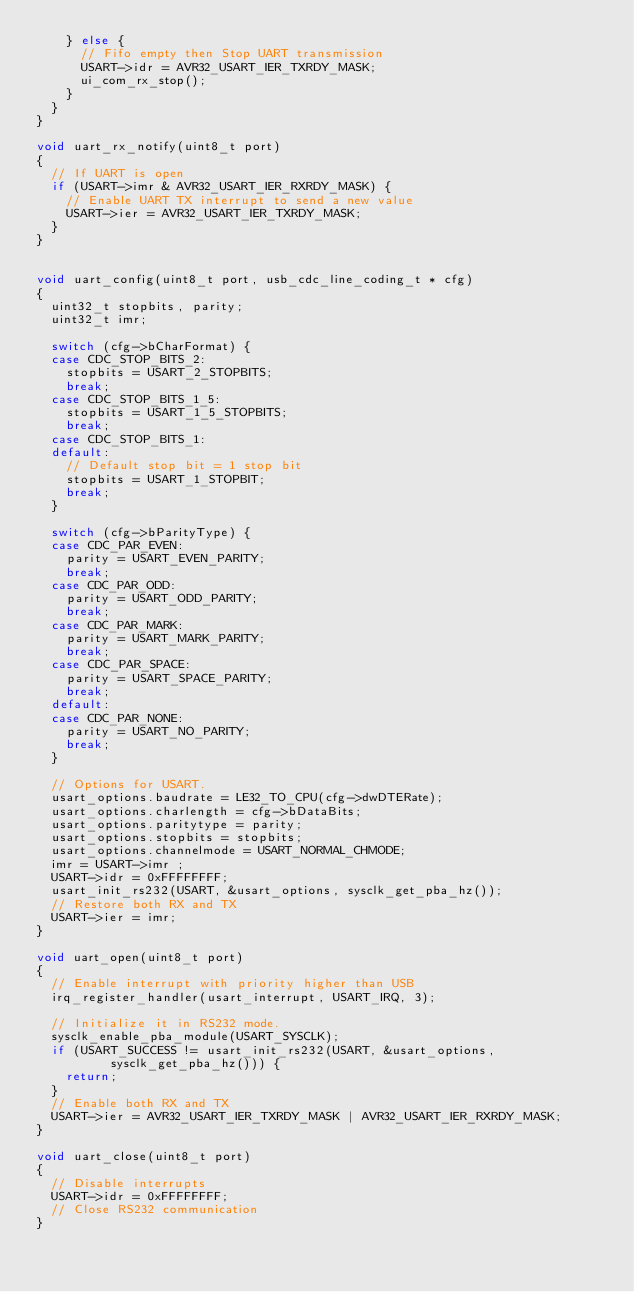<code> <loc_0><loc_0><loc_500><loc_500><_C_>		} else {
			// Fifo empty then Stop UART transmission
			USART->idr = AVR32_USART_IER_TXRDY_MASK;
			ui_com_rx_stop();
		}
	}
}

void uart_rx_notify(uint8_t port)
{
	// If UART is open
	if (USART->imr & AVR32_USART_IER_RXRDY_MASK) {
		// Enable UART TX interrupt to send a new value
		USART->ier = AVR32_USART_IER_TXRDY_MASK;
	}
}


void uart_config(uint8_t port, usb_cdc_line_coding_t * cfg)
{
	uint32_t stopbits, parity;
	uint32_t imr;

	switch (cfg->bCharFormat) {
	case CDC_STOP_BITS_2:
		stopbits = USART_2_STOPBITS;
		break;
	case CDC_STOP_BITS_1_5:
		stopbits = USART_1_5_STOPBITS;
		break;
	case CDC_STOP_BITS_1:
	default:
		// Default stop bit = 1 stop bit
		stopbits = USART_1_STOPBIT;
		break;
	}

	switch (cfg->bParityType) {
	case CDC_PAR_EVEN:
		parity = USART_EVEN_PARITY;
		break;
	case CDC_PAR_ODD:
		parity = USART_ODD_PARITY;
		break;
	case CDC_PAR_MARK:
		parity = USART_MARK_PARITY;
		break;
	case CDC_PAR_SPACE:
		parity = USART_SPACE_PARITY;
		break;
	default:
	case CDC_PAR_NONE:
		parity = USART_NO_PARITY;
		break;
	}

	// Options for USART.
	usart_options.baudrate = LE32_TO_CPU(cfg->dwDTERate);
	usart_options.charlength = cfg->bDataBits;
	usart_options.paritytype = parity;
	usart_options.stopbits = stopbits;
	usart_options.channelmode = USART_NORMAL_CHMODE;
	imr = USART->imr ;
	USART->idr = 0xFFFFFFFF;
	usart_init_rs232(USART, &usart_options, sysclk_get_pba_hz());
	// Restore both RX and TX
	USART->ier = imr;
}

void uart_open(uint8_t port)
{
	// Enable interrupt with priority higher than USB
	irq_register_handler(usart_interrupt, USART_IRQ, 3);

	// Initialize it in RS232 mode.
	sysclk_enable_pba_module(USART_SYSCLK);
	if (USART_SUCCESS != usart_init_rs232(USART, &usart_options,
					sysclk_get_pba_hz())) {
		return;
	}
	// Enable both RX and TX
	USART->ier = AVR32_USART_IER_TXRDY_MASK | AVR32_USART_IER_RXRDY_MASK;
}

void uart_close(uint8_t port)
{
	// Disable interrupts
	USART->idr = 0xFFFFFFFF;
	// Close RS232 communication
}
</code> 